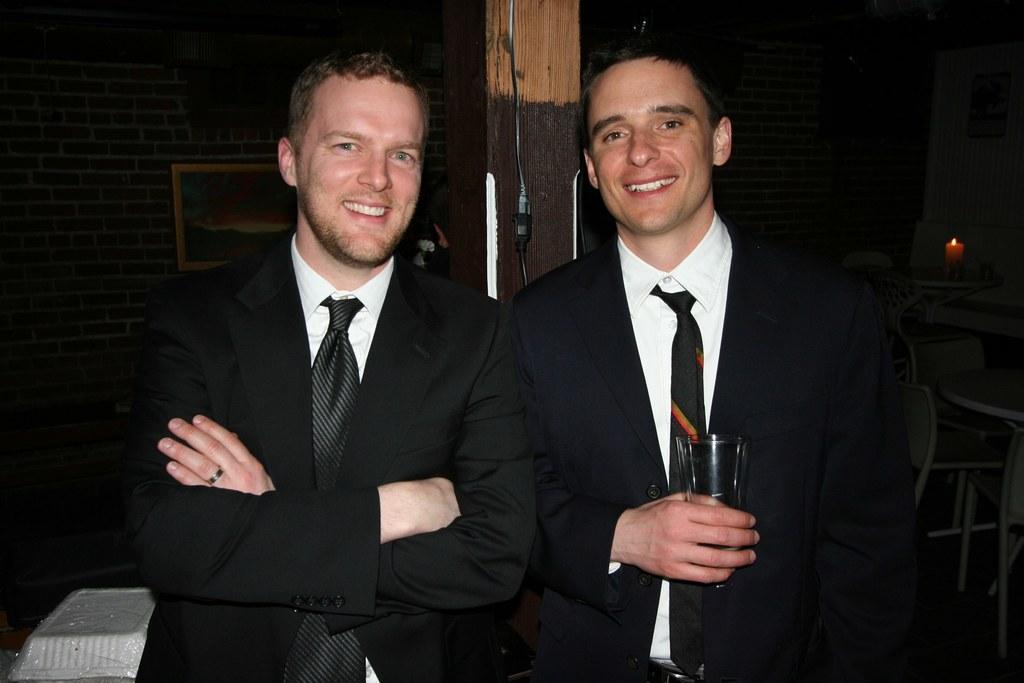In one or two sentences, can you explain what this image depicts? In this image I can see there are two persons wearing a black color suit and they are smiling and on the right side person he holding a glass and background is dark. 